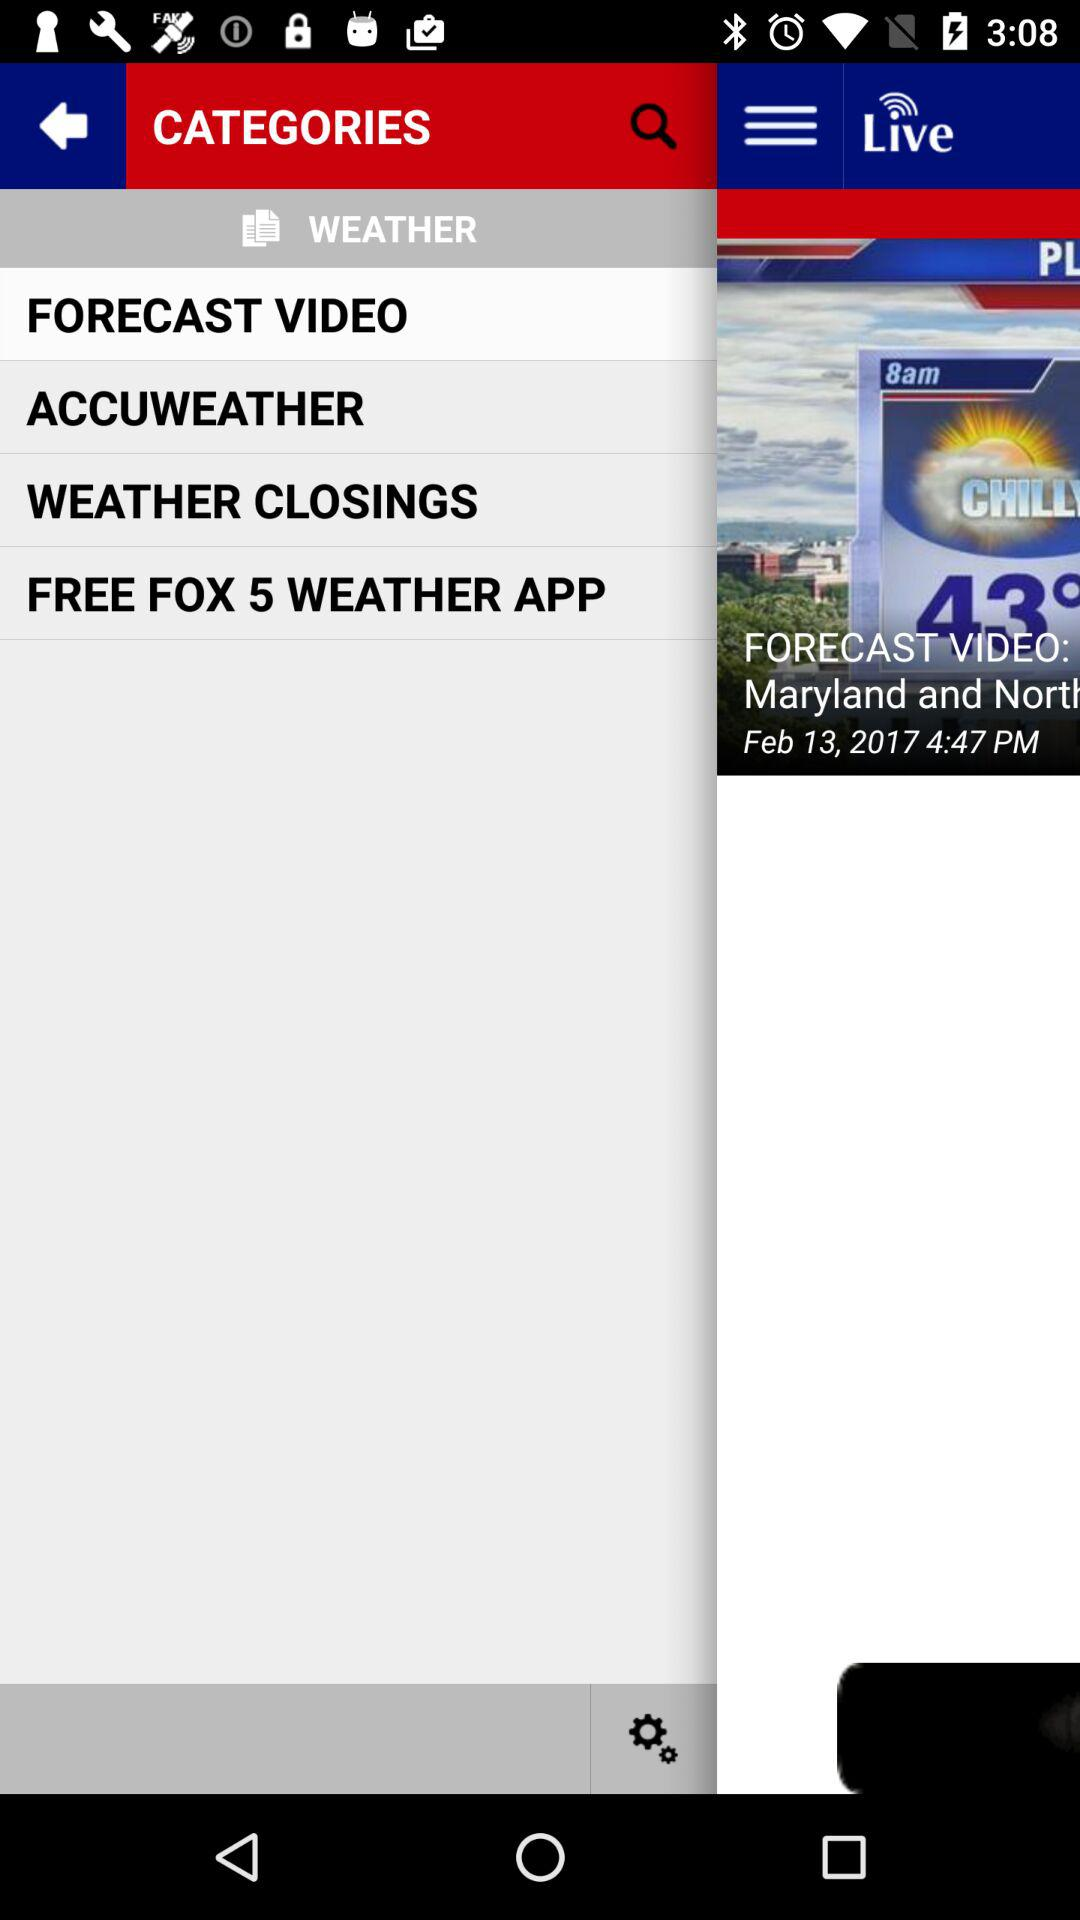On what date was the news posted? The news was posted on February 13, 2017. 